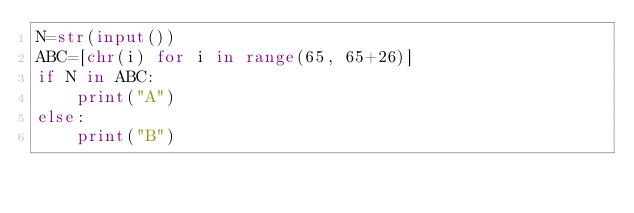<code> <loc_0><loc_0><loc_500><loc_500><_Python_>N=str(input())
ABC=[chr(i) for i in range(65, 65+26)]
if N in ABC:
    print("A")
else:
    print("B")</code> 